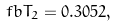<formula> <loc_0><loc_0><loc_500><loc_500>\ f b { T } _ { 2 } = 0 . 3 0 5 2 ,</formula> 